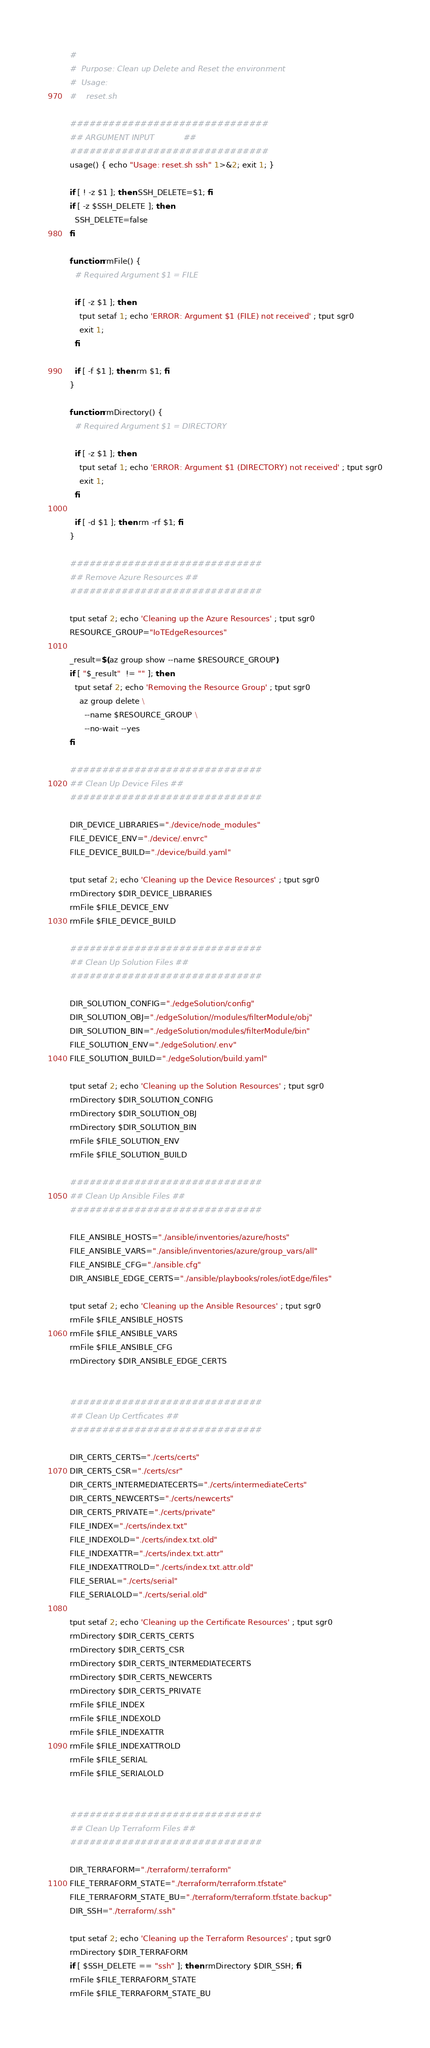<code> <loc_0><loc_0><loc_500><loc_500><_Bash_>#
#  Purpose: Clean up Delete and Reset the environment
#  Usage:
#    reset.sh

###############################
## ARGUMENT INPUT            ##
###############################
usage() { echo "Usage: reset.sh ssh" 1>&2; exit 1; }

if [ ! -z $1 ]; then SSH_DELETE=$1; fi
if [ -z $SSH_DELETE ]; then
  SSH_DELETE=false
fi

function rmFile() {
  # Required Argument $1 = FILE

  if [ -z $1 ]; then
    tput setaf 1; echo 'ERROR: Argument $1 (FILE) not received' ; tput sgr0
    exit 1;
  fi

  if [ -f $1 ]; then rm $1; fi
}

function rmDirectory() {
  # Required Argument $1 = DIRECTORY

  if [ -z $1 ]; then
    tput setaf 1; echo 'ERROR: Argument $1 (DIRECTORY) not received' ; tput sgr0
    exit 1;
  fi

  if [ -d $1 ]; then rm -rf $1; fi
}

##############################
## Remove Azure Resources ##
##############################

tput setaf 2; echo 'Cleaning up the Azure Resources' ; tput sgr0
RESOURCE_GROUP="IoTEdgeResources"

_result=$(az group show --name $RESOURCE_GROUP)
if [ "$_result"  != "" ]; then
  tput setaf 2; echo 'Removing the Resource Group' ; tput sgr0
    az group delete \
      --name $RESOURCE_GROUP \
      --no-wait --yes
fi

##############################
## Clean Up Device Files ##
##############################

DIR_DEVICE_LIBRARIES="./device/node_modules"
FILE_DEVICE_ENV="./device/.envrc"
FILE_DEVICE_BUILD="./device/build.yaml"

tput setaf 2; echo 'Cleaning up the Device Resources' ; tput sgr0
rmDirectory $DIR_DEVICE_LIBRARIES
rmFile $FILE_DEVICE_ENV
rmFile $FILE_DEVICE_BUILD

##############################
## Clean Up Solution Files ##
##############################

DIR_SOLUTION_CONFIG="./edgeSolution/config"
DIR_SOLUTION_OBJ="./edgeSolution//modules/filterModule/obj"
DIR_SOLUTION_BIN="./edgeSolution/modules/filterModule/bin"
FILE_SOLUTION_ENV="./edgeSolution/.env"
FILE_SOLUTION_BUILD="./edgeSolution/build.yaml"

tput setaf 2; echo 'Cleaning up the Solution Resources' ; tput sgr0
rmDirectory $DIR_SOLUTION_CONFIG
rmDirectory $DIR_SOLUTION_OBJ
rmDirectory $DIR_SOLUTION_BIN
rmFile $FILE_SOLUTION_ENV
rmFile $FILE_SOLUTION_BUILD

##############################
## Clean Up Ansible Files ##
##############################

FILE_ANSIBLE_HOSTS="./ansible/inventories/azure/hosts"
FILE_ANSIBLE_VARS="./ansible/inventories/azure/group_vars/all"
FILE_ANSIBLE_CFG="./ansible.cfg"
DIR_ANSIBLE_EDGE_CERTS="./ansible/playbooks/roles/iotEdge/files"

tput setaf 2; echo 'Cleaning up the Ansible Resources' ; tput sgr0
rmFile $FILE_ANSIBLE_HOSTS
rmFile $FILE_ANSIBLE_VARS
rmFile $FILE_ANSIBLE_CFG
rmDirectory $DIR_ANSIBLE_EDGE_CERTS


##############################
## Clean Up Certficates ##
##############################

DIR_CERTS_CERTS="./certs/certs"
DIR_CERTS_CSR="./certs/csr"
DIR_CERTS_INTERMEDIATECERTS="./certs/intermediateCerts"
DIR_CERTS_NEWCERTS="./certs/newcerts"
DIR_CERTS_PRIVATE="./certs/private"
FILE_INDEX="./certs/index.txt"
FILE_INDEXOLD="./certs/index.txt.old"
FILE_INDEXATTR="./certs/index.txt.attr"
FILE_INDEXATTROLD="./certs/index.txt.attr.old"
FILE_SERIAL="./certs/serial"
FILE_SERIALOLD="./certs/serial.old"

tput setaf 2; echo 'Cleaning up the Certificate Resources' ; tput sgr0
rmDirectory $DIR_CERTS_CERTS
rmDirectory $DIR_CERTS_CSR
rmDirectory $DIR_CERTS_INTERMEDIATECERTS
rmDirectory $DIR_CERTS_NEWCERTS
rmDirectory $DIR_CERTS_PRIVATE
rmFile $FILE_INDEX
rmFile $FILE_INDEXOLD
rmFile $FILE_INDEXATTR
rmFile $FILE_INDEXATTROLD
rmFile $FILE_SERIAL
rmFile $FILE_SERIALOLD


##############################
## Clean Up Terraform Files ##
##############################

DIR_TERRAFORM="./terraform/.terraform"
FILE_TERRAFORM_STATE="./terraform/terraform.tfstate"
FILE_TERRAFORM_STATE_BU="./terraform/terraform.tfstate.backup"
DIR_SSH="./terraform/.ssh"

tput setaf 2; echo 'Cleaning up the Terraform Resources' ; tput sgr0
rmDirectory $DIR_TERRAFORM
if [ $SSH_DELETE == "ssh" ]; then rmDirectory $DIR_SSH; fi
rmFile $FILE_TERRAFORM_STATE
rmFile $FILE_TERRAFORM_STATE_BU
</code> 